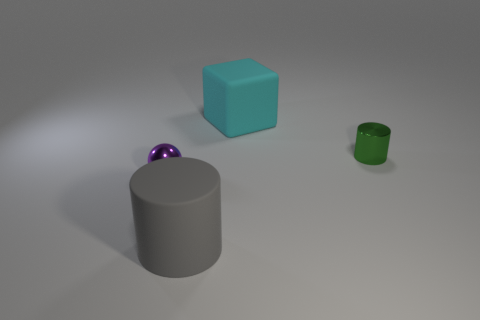Is the color of the ball the same as the matte thing to the right of the large gray matte cylinder?
Ensure brevity in your answer.  No. There is a purple thing that is the same size as the shiny cylinder; what is it made of?
Provide a short and direct response. Metal. What number of objects are either gray objects or things to the right of the gray matte object?
Give a very brief answer. 3. There is a purple shiny object; does it have the same size as the metal object to the right of the rubber block?
Your answer should be very brief. Yes. What number of spheres are either tiny objects or green objects?
Offer a terse response. 1. How many cylinders are both in front of the small purple sphere and on the right side of the big gray object?
Your answer should be compact. 0. The large object that is right of the gray thing has what shape?
Keep it short and to the point. Cube. Is the material of the ball the same as the tiny green cylinder?
Ensure brevity in your answer.  Yes. Is there anything else that is the same size as the green object?
Give a very brief answer. Yes. There is a matte cube; how many large gray cylinders are left of it?
Keep it short and to the point. 1. 